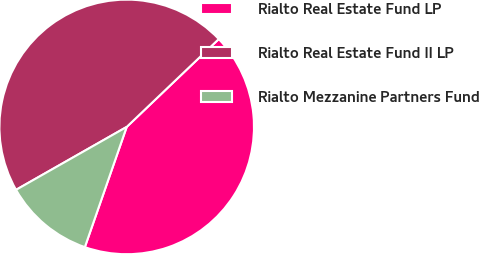Convert chart. <chart><loc_0><loc_0><loc_500><loc_500><pie_chart><fcel>Rialto Real Estate Fund LP<fcel>Rialto Real Estate Fund II LP<fcel>Rialto Mezzanine Partners Fund<nl><fcel>42.46%<fcel>46.1%<fcel>11.44%<nl></chart> 